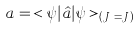<formula> <loc_0><loc_0><loc_500><loc_500>a = \, < \psi | \hat { a } | \psi > _ { ( J _ { z } = J ) }</formula> 